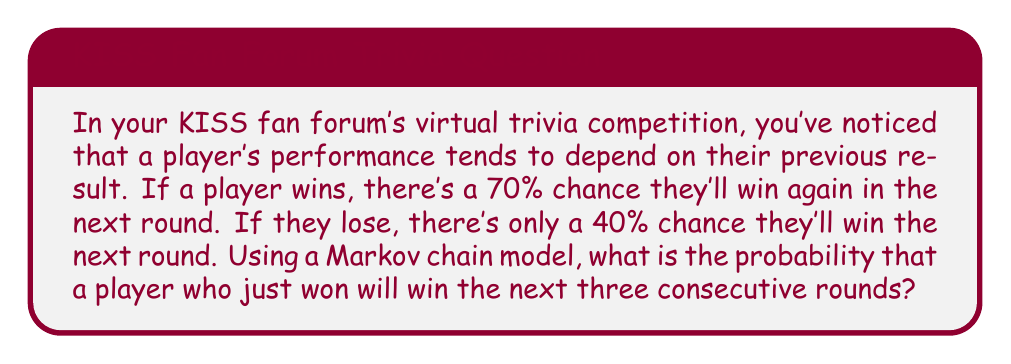What is the answer to this math problem? Let's approach this step-by-step using a Markov chain:

1) First, we need to identify the states and transition probabilities:
   - State W: Win
   - State L: Lose

   Transition probabilities:
   - P(W|W) = 0.70 (probability of winning given a previous win)
   - P(L|W) = 0.30 (probability of losing given a previous win)
   - P(W|L) = 0.40 (probability of winning given a previous loss)
   - P(L|L) = 0.60 (probability of losing given a previous loss)

2) We're interested in the probability of winning three consecutive rounds after an initial win. This can be represented as:

   P(W → W → W → W)

3) Using the Markov property, we can calculate this as:

   P(W → W → W → W) = P(W|W) * P(W|W) * P(W|W)

4) Substituting the values:

   P(W → W → W → W) = 0.70 * 0.70 * 0.70

5) Calculating:

   P(W → W → W → W) = 0.343 or 34.3%

Therefore, the probability of a player winning the next three consecutive rounds after an initial win is approximately 0.343 or 34.3%.
Answer: 0.343 